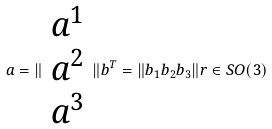<formula> <loc_0><loc_0><loc_500><loc_500>a = \| \begin{array} { c } a ^ { 1 } \\ a ^ { 2 } \\ a ^ { 3 } \end{array} \| b ^ { T } = \| b _ { 1 } b _ { 2 } b _ { 3 } \| r \in S O ( 3 )</formula> 